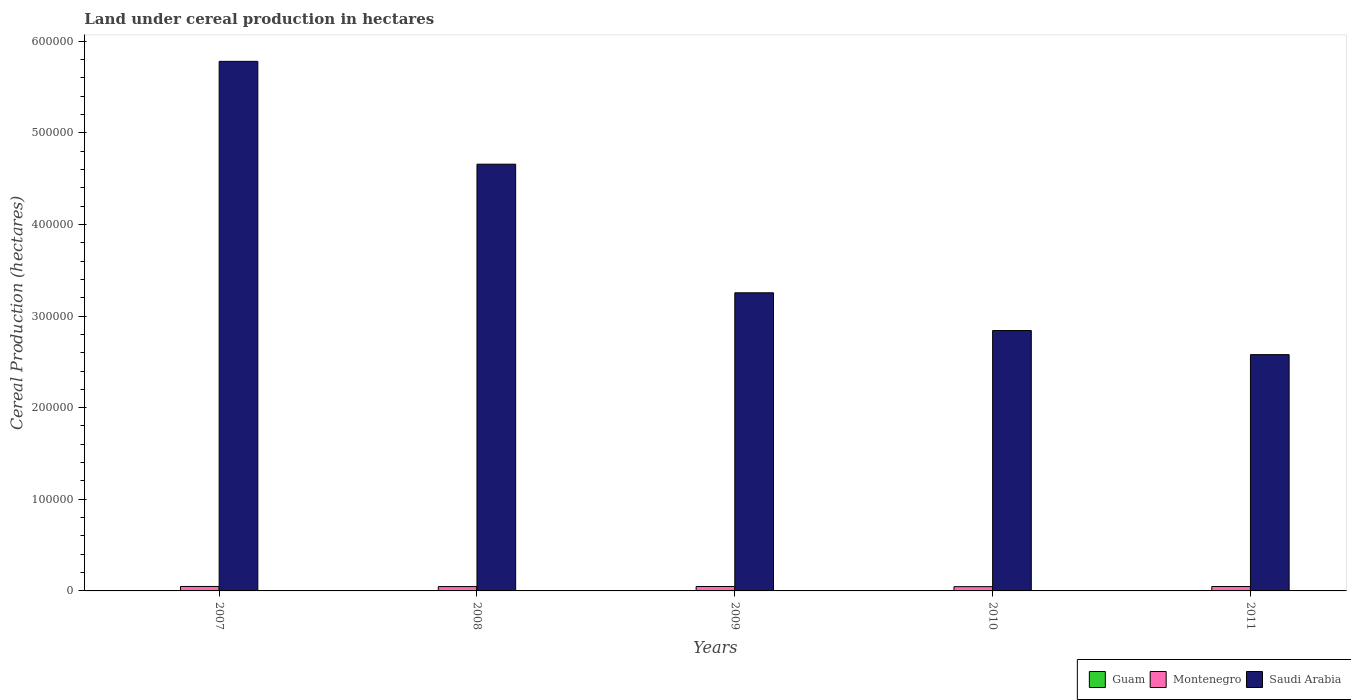How many different coloured bars are there?
Your answer should be compact. 3. Are the number of bars per tick equal to the number of legend labels?
Provide a succinct answer. Yes. How many bars are there on the 4th tick from the left?
Your answer should be very brief. 3. What is the label of the 4th group of bars from the left?
Your response must be concise. 2010. What is the land under cereal production in Saudi Arabia in 2011?
Offer a very short reply. 2.58e+05. Across all years, what is the maximum land under cereal production in Guam?
Offer a terse response. 19. Across all years, what is the minimum land under cereal production in Montenegro?
Keep it short and to the point. 4653. What is the total land under cereal production in Guam in the graph?
Provide a succinct answer. 83. What is the difference between the land under cereal production in Guam in 2008 and the land under cereal production in Saudi Arabia in 2011?
Offer a very short reply. -2.58e+05. What is the average land under cereal production in Guam per year?
Keep it short and to the point. 16.6. In the year 2009, what is the difference between the land under cereal production in Montenegro and land under cereal production in Guam?
Your answer should be very brief. 4826. What is the ratio of the land under cereal production in Guam in 2007 to that in 2010?
Keep it short and to the point. 0.83. Is the difference between the land under cereal production in Montenegro in 2007 and 2010 greater than the difference between the land under cereal production in Guam in 2007 and 2010?
Provide a succinct answer. Yes. What is the difference between the highest and the second highest land under cereal production in Guam?
Provide a succinct answer. 1. What is the difference between the highest and the lowest land under cereal production in Guam?
Make the answer very short. 4. What does the 3rd bar from the left in 2009 represents?
Offer a terse response. Saudi Arabia. What does the 1st bar from the right in 2007 represents?
Your answer should be very brief. Saudi Arabia. How many bars are there?
Your answer should be very brief. 15. How many legend labels are there?
Give a very brief answer. 3. What is the title of the graph?
Your answer should be compact. Land under cereal production in hectares. Does "South Asia" appear as one of the legend labels in the graph?
Your answer should be very brief. No. What is the label or title of the Y-axis?
Give a very brief answer. Cereal Production (hectares). What is the Cereal Production (hectares) of Montenegro in 2007?
Provide a succinct answer. 4847. What is the Cereal Production (hectares) in Saudi Arabia in 2007?
Keep it short and to the point. 5.78e+05. What is the Cereal Production (hectares) in Montenegro in 2008?
Offer a very short reply. 4746. What is the Cereal Production (hectares) in Saudi Arabia in 2008?
Provide a short and direct response. 4.66e+05. What is the Cereal Production (hectares) in Montenegro in 2009?
Ensure brevity in your answer.  4841. What is the Cereal Production (hectares) of Saudi Arabia in 2009?
Ensure brevity in your answer.  3.25e+05. What is the Cereal Production (hectares) in Montenegro in 2010?
Your answer should be very brief. 4653. What is the Cereal Production (hectares) in Saudi Arabia in 2010?
Keep it short and to the point. 2.84e+05. What is the Cereal Production (hectares) of Guam in 2011?
Offer a very short reply. 19. What is the Cereal Production (hectares) of Montenegro in 2011?
Your answer should be very brief. 4795. What is the Cereal Production (hectares) of Saudi Arabia in 2011?
Make the answer very short. 2.58e+05. Across all years, what is the maximum Cereal Production (hectares) of Montenegro?
Your answer should be compact. 4847. Across all years, what is the maximum Cereal Production (hectares) of Saudi Arabia?
Give a very brief answer. 5.78e+05. Across all years, what is the minimum Cereal Production (hectares) of Guam?
Make the answer very short. 15. Across all years, what is the minimum Cereal Production (hectares) in Montenegro?
Provide a short and direct response. 4653. Across all years, what is the minimum Cereal Production (hectares) of Saudi Arabia?
Your answer should be compact. 2.58e+05. What is the total Cereal Production (hectares) of Guam in the graph?
Your response must be concise. 83. What is the total Cereal Production (hectares) of Montenegro in the graph?
Ensure brevity in your answer.  2.39e+04. What is the total Cereal Production (hectares) in Saudi Arabia in the graph?
Offer a terse response. 1.91e+06. What is the difference between the Cereal Production (hectares) of Montenegro in 2007 and that in 2008?
Provide a succinct answer. 101. What is the difference between the Cereal Production (hectares) in Saudi Arabia in 2007 and that in 2008?
Your answer should be compact. 1.12e+05. What is the difference between the Cereal Production (hectares) of Saudi Arabia in 2007 and that in 2009?
Your response must be concise. 2.53e+05. What is the difference between the Cereal Production (hectares) in Montenegro in 2007 and that in 2010?
Provide a succinct answer. 194. What is the difference between the Cereal Production (hectares) of Saudi Arabia in 2007 and that in 2010?
Your response must be concise. 2.94e+05. What is the difference between the Cereal Production (hectares) in Guam in 2007 and that in 2011?
Give a very brief answer. -4. What is the difference between the Cereal Production (hectares) in Saudi Arabia in 2007 and that in 2011?
Offer a very short reply. 3.20e+05. What is the difference between the Cereal Production (hectares) of Montenegro in 2008 and that in 2009?
Offer a very short reply. -95. What is the difference between the Cereal Production (hectares) of Saudi Arabia in 2008 and that in 2009?
Make the answer very short. 1.40e+05. What is the difference between the Cereal Production (hectares) in Guam in 2008 and that in 2010?
Provide a succinct answer. -2. What is the difference between the Cereal Production (hectares) in Montenegro in 2008 and that in 2010?
Provide a short and direct response. 93. What is the difference between the Cereal Production (hectares) of Saudi Arabia in 2008 and that in 2010?
Offer a very short reply. 1.82e+05. What is the difference between the Cereal Production (hectares) in Montenegro in 2008 and that in 2011?
Your answer should be compact. -49. What is the difference between the Cereal Production (hectares) of Saudi Arabia in 2008 and that in 2011?
Ensure brevity in your answer.  2.08e+05. What is the difference between the Cereal Production (hectares) of Guam in 2009 and that in 2010?
Make the answer very short. -3. What is the difference between the Cereal Production (hectares) of Montenegro in 2009 and that in 2010?
Offer a very short reply. 188. What is the difference between the Cereal Production (hectares) in Saudi Arabia in 2009 and that in 2010?
Offer a terse response. 4.12e+04. What is the difference between the Cereal Production (hectares) of Saudi Arabia in 2009 and that in 2011?
Keep it short and to the point. 6.75e+04. What is the difference between the Cereal Production (hectares) in Montenegro in 2010 and that in 2011?
Your answer should be compact. -142. What is the difference between the Cereal Production (hectares) in Saudi Arabia in 2010 and that in 2011?
Your answer should be compact. 2.63e+04. What is the difference between the Cereal Production (hectares) of Guam in 2007 and the Cereal Production (hectares) of Montenegro in 2008?
Your answer should be very brief. -4731. What is the difference between the Cereal Production (hectares) in Guam in 2007 and the Cereal Production (hectares) in Saudi Arabia in 2008?
Provide a short and direct response. -4.66e+05. What is the difference between the Cereal Production (hectares) in Montenegro in 2007 and the Cereal Production (hectares) in Saudi Arabia in 2008?
Give a very brief answer. -4.61e+05. What is the difference between the Cereal Production (hectares) of Guam in 2007 and the Cereal Production (hectares) of Montenegro in 2009?
Provide a short and direct response. -4826. What is the difference between the Cereal Production (hectares) of Guam in 2007 and the Cereal Production (hectares) of Saudi Arabia in 2009?
Make the answer very short. -3.25e+05. What is the difference between the Cereal Production (hectares) in Montenegro in 2007 and the Cereal Production (hectares) in Saudi Arabia in 2009?
Provide a succinct answer. -3.21e+05. What is the difference between the Cereal Production (hectares) of Guam in 2007 and the Cereal Production (hectares) of Montenegro in 2010?
Offer a terse response. -4638. What is the difference between the Cereal Production (hectares) of Guam in 2007 and the Cereal Production (hectares) of Saudi Arabia in 2010?
Make the answer very short. -2.84e+05. What is the difference between the Cereal Production (hectares) of Montenegro in 2007 and the Cereal Production (hectares) of Saudi Arabia in 2010?
Give a very brief answer. -2.79e+05. What is the difference between the Cereal Production (hectares) in Guam in 2007 and the Cereal Production (hectares) in Montenegro in 2011?
Your response must be concise. -4780. What is the difference between the Cereal Production (hectares) in Guam in 2007 and the Cereal Production (hectares) in Saudi Arabia in 2011?
Make the answer very short. -2.58e+05. What is the difference between the Cereal Production (hectares) of Montenegro in 2007 and the Cereal Production (hectares) of Saudi Arabia in 2011?
Your answer should be compact. -2.53e+05. What is the difference between the Cereal Production (hectares) in Guam in 2008 and the Cereal Production (hectares) in Montenegro in 2009?
Provide a short and direct response. -4825. What is the difference between the Cereal Production (hectares) of Guam in 2008 and the Cereal Production (hectares) of Saudi Arabia in 2009?
Your answer should be very brief. -3.25e+05. What is the difference between the Cereal Production (hectares) in Montenegro in 2008 and the Cereal Production (hectares) in Saudi Arabia in 2009?
Give a very brief answer. -3.21e+05. What is the difference between the Cereal Production (hectares) of Guam in 2008 and the Cereal Production (hectares) of Montenegro in 2010?
Provide a short and direct response. -4637. What is the difference between the Cereal Production (hectares) in Guam in 2008 and the Cereal Production (hectares) in Saudi Arabia in 2010?
Provide a succinct answer. -2.84e+05. What is the difference between the Cereal Production (hectares) of Montenegro in 2008 and the Cereal Production (hectares) of Saudi Arabia in 2010?
Provide a short and direct response. -2.79e+05. What is the difference between the Cereal Production (hectares) in Guam in 2008 and the Cereal Production (hectares) in Montenegro in 2011?
Give a very brief answer. -4779. What is the difference between the Cereal Production (hectares) in Guam in 2008 and the Cereal Production (hectares) in Saudi Arabia in 2011?
Provide a succinct answer. -2.58e+05. What is the difference between the Cereal Production (hectares) of Montenegro in 2008 and the Cereal Production (hectares) of Saudi Arabia in 2011?
Your response must be concise. -2.53e+05. What is the difference between the Cereal Production (hectares) in Guam in 2009 and the Cereal Production (hectares) in Montenegro in 2010?
Make the answer very short. -4638. What is the difference between the Cereal Production (hectares) in Guam in 2009 and the Cereal Production (hectares) in Saudi Arabia in 2010?
Provide a short and direct response. -2.84e+05. What is the difference between the Cereal Production (hectares) of Montenegro in 2009 and the Cereal Production (hectares) of Saudi Arabia in 2010?
Provide a succinct answer. -2.79e+05. What is the difference between the Cereal Production (hectares) of Guam in 2009 and the Cereal Production (hectares) of Montenegro in 2011?
Keep it short and to the point. -4780. What is the difference between the Cereal Production (hectares) of Guam in 2009 and the Cereal Production (hectares) of Saudi Arabia in 2011?
Give a very brief answer. -2.58e+05. What is the difference between the Cereal Production (hectares) in Montenegro in 2009 and the Cereal Production (hectares) in Saudi Arabia in 2011?
Offer a terse response. -2.53e+05. What is the difference between the Cereal Production (hectares) in Guam in 2010 and the Cereal Production (hectares) in Montenegro in 2011?
Give a very brief answer. -4777. What is the difference between the Cereal Production (hectares) of Guam in 2010 and the Cereal Production (hectares) of Saudi Arabia in 2011?
Your response must be concise. -2.58e+05. What is the difference between the Cereal Production (hectares) of Montenegro in 2010 and the Cereal Production (hectares) of Saudi Arabia in 2011?
Make the answer very short. -2.53e+05. What is the average Cereal Production (hectares) of Guam per year?
Your answer should be very brief. 16.6. What is the average Cereal Production (hectares) of Montenegro per year?
Your answer should be very brief. 4776.4. What is the average Cereal Production (hectares) of Saudi Arabia per year?
Provide a succinct answer. 3.82e+05. In the year 2007, what is the difference between the Cereal Production (hectares) in Guam and Cereal Production (hectares) in Montenegro?
Your answer should be very brief. -4832. In the year 2007, what is the difference between the Cereal Production (hectares) in Guam and Cereal Production (hectares) in Saudi Arabia?
Offer a terse response. -5.78e+05. In the year 2007, what is the difference between the Cereal Production (hectares) in Montenegro and Cereal Production (hectares) in Saudi Arabia?
Your answer should be compact. -5.73e+05. In the year 2008, what is the difference between the Cereal Production (hectares) in Guam and Cereal Production (hectares) in Montenegro?
Provide a short and direct response. -4730. In the year 2008, what is the difference between the Cereal Production (hectares) of Guam and Cereal Production (hectares) of Saudi Arabia?
Provide a succinct answer. -4.66e+05. In the year 2008, what is the difference between the Cereal Production (hectares) of Montenegro and Cereal Production (hectares) of Saudi Arabia?
Provide a short and direct response. -4.61e+05. In the year 2009, what is the difference between the Cereal Production (hectares) of Guam and Cereal Production (hectares) of Montenegro?
Keep it short and to the point. -4826. In the year 2009, what is the difference between the Cereal Production (hectares) in Guam and Cereal Production (hectares) in Saudi Arabia?
Offer a very short reply. -3.25e+05. In the year 2009, what is the difference between the Cereal Production (hectares) in Montenegro and Cereal Production (hectares) in Saudi Arabia?
Your answer should be very brief. -3.21e+05. In the year 2010, what is the difference between the Cereal Production (hectares) in Guam and Cereal Production (hectares) in Montenegro?
Make the answer very short. -4635. In the year 2010, what is the difference between the Cereal Production (hectares) of Guam and Cereal Production (hectares) of Saudi Arabia?
Ensure brevity in your answer.  -2.84e+05. In the year 2010, what is the difference between the Cereal Production (hectares) of Montenegro and Cereal Production (hectares) of Saudi Arabia?
Give a very brief answer. -2.80e+05. In the year 2011, what is the difference between the Cereal Production (hectares) of Guam and Cereal Production (hectares) of Montenegro?
Provide a short and direct response. -4776. In the year 2011, what is the difference between the Cereal Production (hectares) of Guam and Cereal Production (hectares) of Saudi Arabia?
Keep it short and to the point. -2.58e+05. In the year 2011, what is the difference between the Cereal Production (hectares) of Montenegro and Cereal Production (hectares) of Saudi Arabia?
Your answer should be very brief. -2.53e+05. What is the ratio of the Cereal Production (hectares) of Guam in 2007 to that in 2008?
Make the answer very short. 0.94. What is the ratio of the Cereal Production (hectares) in Montenegro in 2007 to that in 2008?
Provide a short and direct response. 1.02. What is the ratio of the Cereal Production (hectares) of Saudi Arabia in 2007 to that in 2008?
Ensure brevity in your answer.  1.24. What is the ratio of the Cereal Production (hectares) of Guam in 2007 to that in 2009?
Give a very brief answer. 1. What is the ratio of the Cereal Production (hectares) of Montenegro in 2007 to that in 2009?
Your response must be concise. 1. What is the ratio of the Cereal Production (hectares) of Saudi Arabia in 2007 to that in 2009?
Make the answer very short. 1.78. What is the ratio of the Cereal Production (hectares) in Montenegro in 2007 to that in 2010?
Ensure brevity in your answer.  1.04. What is the ratio of the Cereal Production (hectares) of Saudi Arabia in 2007 to that in 2010?
Make the answer very short. 2.03. What is the ratio of the Cereal Production (hectares) in Guam in 2007 to that in 2011?
Ensure brevity in your answer.  0.79. What is the ratio of the Cereal Production (hectares) in Montenegro in 2007 to that in 2011?
Provide a succinct answer. 1.01. What is the ratio of the Cereal Production (hectares) in Saudi Arabia in 2007 to that in 2011?
Offer a terse response. 2.24. What is the ratio of the Cereal Production (hectares) in Guam in 2008 to that in 2009?
Keep it short and to the point. 1.07. What is the ratio of the Cereal Production (hectares) in Montenegro in 2008 to that in 2009?
Your response must be concise. 0.98. What is the ratio of the Cereal Production (hectares) of Saudi Arabia in 2008 to that in 2009?
Provide a succinct answer. 1.43. What is the ratio of the Cereal Production (hectares) in Saudi Arabia in 2008 to that in 2010?
Offer a very short reply. 1.64. What is the ratio of the Cereal Production (hectares) in Guam in 2008 to that in 2011?
Make the answer very short. 0.84. What is the ratio of the Cereal Production (hectares) of Saudi Arabia in 2008 to that in 2011?
Offer a terse response. 1.81. What is the ratio of the Cereal Production (hectares) of Montenegro in 2009 to that in 2010?
Provide a short and direct response. 1.04. What is the ratio of the Cereal Production (hectares) of Saudi Arabia in 2009 to that in 2010?
Provide a short and direct response. 1.15. What is the ratio of the Cereal Production (hectares) in Guam in 2009 to that in 2011?
Give a very brief answer. 0.79. What is the ratio of the Cereal Production (hectares) in Montenegro in 2009 to that in 2011?
Offer a very short reply. 1.01. What is the ratio of the Cereal Production (hectares) in Saudi Arabia in 2009 to that in 2011?
Ensure brevity in your answer.  1.26. What is the ratio of the Cereal Production (hectares) of Montenegro in 2010 to that in 2011?
Your answer should be very brief. 0.97. What is the ratio of the Cereal Production (hectares) of Saudi Arabia in 2010 to that in 2011?
Offer a very short reply. 1.1. What is the difference between the highest and the second highest Cereal Production (hectares) of Guam?
Offer a terse response. 1. What is the difference between the highest and the second highest Cereal Production (hectares) in Saudi Arabia?
Your answer should be compact. 1.12e+05. What is the difference between the highest and the lowest Cereal Production (hectares) in Montenegro?
Give a very brief answer. 194. What is the difference between the highest and the lowest Cereal Production (hectares) of Saudi Arabia?
Provide a short and direct response. 3.20e+05. 